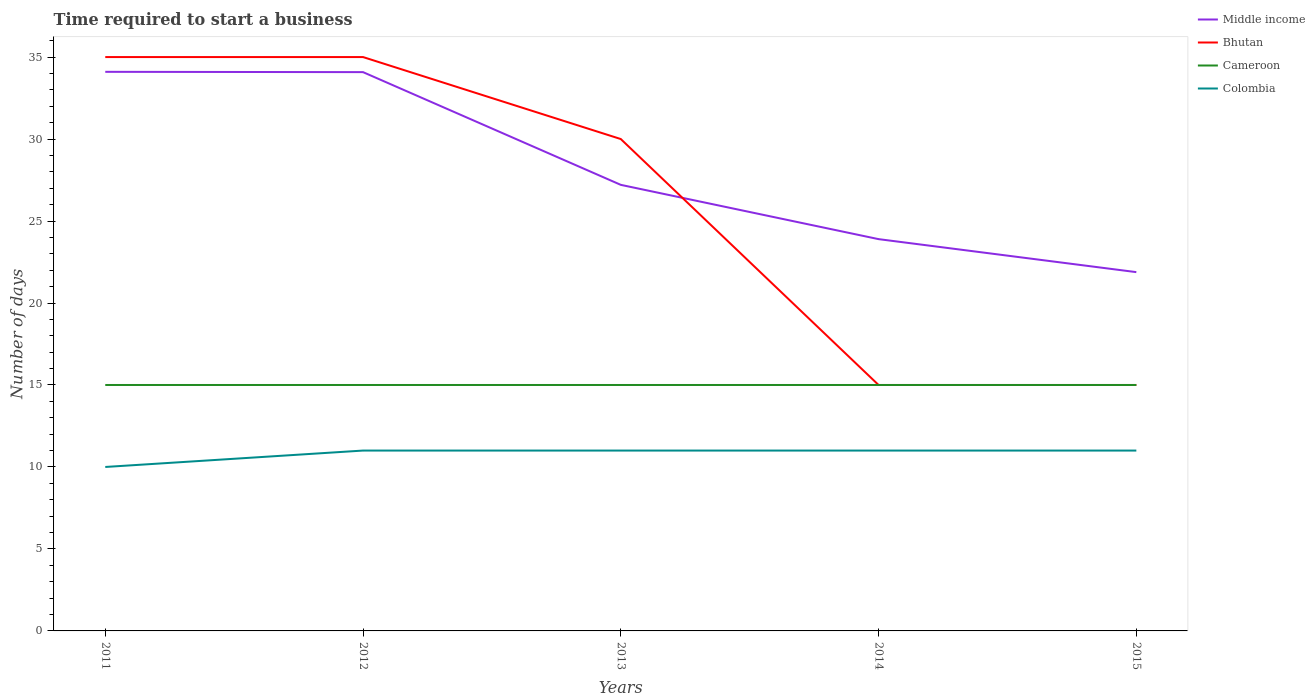How many different coloured lines are there?
Your response must be concise. 4. Is the number of lines equal to the number of legend labels?
Offer a very short reply. Yes. Across all years, what is the maximum number of days required to start a business in Bhutan?
Keep it short and to the point. 15. In which year was the number of days required to start a business in Middle income maximum?
Your answer should be compact. 2015. What is the difference between the highest and the second highest number of days required to start a business in Middle income?
Provide a succinct answer. 12.22. What is the difference between the highest and the lowest number of days required to start a business in Bhutan?
Ensure brevity in your answer.  3. Is the number of days required to start a business in Bhutan strictly greater than the number of days required to start a business in Cameroon over the years?
Offer a very short reply. No. How many lines are there?
Your response must be concise. 4. Are the values on the major ticks of Y-axis written in scientific E-notation?
Your answer should be very brief. No. Where does the legend appear in the graph?
Your answer should be very brief. Top right. How are the legend labels stacked?
Make the answer very short. Vertical. What is the title of the graph?
Ensure brevity in your answer.  Time required to start a business. Does "Greenland" appear as one of the legend labels in the graph?
Give a very brief answer. No. What is the label or title of the X-axis?
Your answer should be compact. Years. What is the label or title of the Y-axis?
Your answer should be compact. Number of days. What is the Number of days in Middle income in 2011?
Provide a succinct answer. 34.1. What is the Number of days in Cameroon in 2011?
Keep it short and to the point. 15. What is the Number of days in Colombia in 2011?
Offer a terse response. 10. What is the Number of days in Middle income in 2012?
Keep it short and to the point. 34.08. What is the Number of days in Bhutan in 2012?
Your response must be concise. 35. What is the Number of days of Cameroon in 2012?
Your response must be concise. 15. What is the Number of days in Colombia in 2012?
Give a very brief answer. 11. What is the Number of days in Middle income in 2013?
Provide a succinct answer. 27.21. What is the Number of days of Bhutan in 2013?
Your answer should be very brief. 30. What is the Number of days in Cameroon in 2013?
Offer a very short reply. 15. What is the Number of days of Colombia in 2013?
Make the answer very short. 11. What is the Number of days in Middle income in 2014?
Ensure brevity in your answer.  23.9. What is the Number of days in Bhutan in 2014?
Your response must be concise. 15. What is the Number of days of Cameroon in 2014?
Offer a terse response. 15. What is the Number of days of Middle income in 2015?
Your answer should be compact. 21.88. What is the Number of days of Bhutan in 2015?
Your answer should be compact. 15. What is the Number of days of Cameroon in 2015?
Provide a succinct answer. 15. Across all years, what is the maximum Number of days in Middle income?
Ensure brevity in your answer.  34.1. Across all years, what is the maximum Number of days of Colombia?
Make the answer very short. 11. Across all years, what is the minimum Number of days in Middle income?
Ensure brevity in your answer.  21.88. Across all years, what is the minimum Number of days of Colombia?
Your answer should be very brief. 10. What is the total Number of days in Middle income in the graph?
Make the answer very short. 141.17. What is the total Number of days in Bhutan in the graph?
Provide a short and direct response. 130. What is the difference between the Number of days in Middle income in 2011 and that in 2012?
Provide a succinct answer. 0.02. What is the difference between the Number of days of Middle income in 2011 and that in 2013?
Your answer should be very brief. 6.89. What is the difference between the Number of days in Bhutan in 2011 and that in 2013?
Offer a terse response. 5. What is the difference between the Number of days of Cameroon in 2011 and that in 2013?
Provide a succinct answer. 0. What is the difference between the Number of days in Middle income in 2011 and that in 2014?
Provide a succinct answer. 10.2. What is the difference between the Number of days in Bhutan in 2011 and that in 2014?
Offer a terse response. 20. What is the difference between the Number of days in Cameroon in 2011 and that in 2014?
Make the answer very short. 0. What is the difference between the Number of days of Colombia in 2011 and that in 2014?
Provide a short and direct response. -1. What is the difference between the Number of days of Middle income in 2011 and that in 2015?
Your answer should be compact. 12.22. What is the difference between the Number of days of Cameroon in 2011 and that in 2015?
Offer a very short reply. 0. What is the difference between the Number of days in Middle income in 2012 and that in 2013?
Provide a short and direct response. 6.88. What is the difference between the Number of days of Bhutan in 2012 and that in 2013?
Your answer should be compact. 5. What is the difference between the Number of days in Colombia in 2012 and that in 2013?
Your response must be concise. 0. What is the difference between the Number of days of Middle income in 2012 and that in 2014?
Offer a very short reply. 10.19. What is the difference between the Number of days of Bhutan in 2012 and that in 2014?
Your answer should be compact. 20. What is the difference between the Number of days of Colombia in 2012 and that in 2014?
Ensure brevity in your answer.  0. What is the difference between the Number of days of Middle income in 2012 and that in 2015?
Your answer should be compact. 12.2. What is the difference between the Number of days in Cameroon in 2012 and that in 2015?
Your response must be concise. 0. What is the difference between the Number of days of Colombia in 2012 and that in 2015?
Give a very brief answer. 0. What is the difference between the Number of days of Middle income in 2013 and that in 2014?
Your answer should be compact. 3.31. What is the difference between the Number of days of Cameroon in 2013 and that in 2014?
Ensure brevity in your answer.  0. What is the difference between the Number of days in Colombia in 2013 and that in 2014?
Ensure brevity in your answer.  0. What is the difference between the Number of days in Middle income in 2013 and that in 2015?
Provide a succinct answer. 5.32. What is the difference between the Number of days in Bhutan in 2013 and that in 2015?
Make the answer very short. 15. What is the difference between the Number of days in Middle income in 2014 and that in 2015?
Provide a succinct answer. 2.01. What is the difference between the Number of days of Bhutan in 2014 and that in 2015?
Ensure brevity in your answer.  0. What is the difference between the Number of days of Cameroon in 2014 and that in 2015?
Your response must be concise. 0. What is the difference between the Number of days of Colombia in 2014 and that in 2015?
Your answer should be very brief. 0. What is the difference between the Number of days of Middle income in 2011 and the Number of days of Bhutan in 2012?
Make the answer very short. -0.9. What is the difference between the Number of days in Middle income in 2011 and the Number of days in Cameroon in 2012?
Offer a terse response. 19.1. What is the difference between the Number of days in Middle income in 2011 and the Number of days in Colombia in 2012?
Offer a very short reply. 23.1. What is the difference between the Number of days of Bhutan in 2011 and the Number of days of Cameroon in 2012?
Offer a very short reply. 20. What is the difference between the Number of days of Bhutan in 2011 and the Number of days of Colombia in 2012?
Your response must be concise. 24. What is the difference between the Number of days of Middle income in 2011 and the Number of days of Bhutan in 2013?
Your response must be concise. 4.1. What is the difference between the Number of days in Middle income in 2011 and the Number of days in Colombia in 2013?
Give a very brief answer. 23.1. What is the difference between the Number of days in Cameroon in 2011 and the Number of days in Colombia in 2013?
Your answer should be compact. 4. What is the difference between the Number of days in Middle income in 2011 and the Number of days in Cameroon in 2014?
Ensure brevity in your answer.  19.1. What is the difference between the Number of days in Middle income in 2011 and the Number of days in Colombia in 2014?
Your answer should be very brief. 23.1. What is the difference between the Number of days of Bhutan in 2011 and the Number of days of Cameroon in 2014?
Your response must be concise. 20. What is the difference between the Number of days in Bhutan in 2011 and the Number of days in Colombia in 2014?
Ensure brevity in your answer.  24. What is the difference between the Number of days in Middle income in 2011 and the Number of days in Bhutan in 2015?
Provide a succinct answer. 19.1. What is the difference between the Number of days in Middle income in 2011 and the Number of days in Cameroon in 2015?
Your answer should be very brief. 19.1. What is the difference between the Number of days of Middle income in 2011 and the Number of days of Colombia in 2015?
Offer a very short reply. 23.1. What is the difference between the Number of days of Bhutan in 2011 and the Number of days of Cameroon in 2015?
Give a very brief answer. 20. What is the difference between the Number of days in Bhutan in 2011 and the Number of days in Colombia in 2015?
Your response must be concise. 24. What is the difference between the Number of days in Cameroon in 2011 and the Number of days in Colombia in 2015?
Your answer should be very brief. 4. What is the difference between the Number of days of Middle income in 2012 and the Number of days of Bhutan in 2013?
Make the answer very short. 4.08. What is the difference between the Number of days of Middle income in 2012 and the Number of days of Cameroon in 2013?
Make the answer very short. 19.08. What is the difference between the Number of days of Middle income in 2012 and the Number of days of Colombia in 2013?
Your answer should be very brief. 23.08. What is the difference between the Number of days in Bhutan in 2012 and the Number of days in Cameroon in 2013?
Give a very brief answer. 20. What is the difference between the Number of days in Cameroon in 2012 and the Number of days in Colombia in 2013?
Your answer should be very brief. 4. What is the difference between the Number of days in Middle income in 2012 and the Number of days in Bhutan in 2014?
Provide a short and direct response. 19.08. What is the difference between the Number of days of Middle income in 2012 and the Number of days of Cameroon in 2014?
Make the answer very short. 19.08. What is the difference between the Number of days of Middle income in 2012 and the Number of days of Colombia in 2014?
Offer a very short reply. 23.08. What is the difference between the Number of days in Bhutan in 2012 and the Number of days in Cameroon in 2014?
Give a very brief answer. 20. What is the difference between the Number of days in Middle income in 2012 and the Number of days in Bhutan in 2015?
Provide a succinct answer. 19.08. What is the difference between the Number of days of Middle income in 2012 and the Number of days of Cameroon in 2015?
Give a very brief answer. 19.08. What is the difference between the Number of days of Middle income in 2012 and the Number of days of Colombia in 2015?
Your answer should be compact. 23.08. What is the difference between the Number of days of Bhutan in 2012 and the Number of days of Cameroon in 2015?
Your answer should be very brief. 20. What is the difference between the Number of days of Bhutan in 2012 and the Number of days of Colombia in 2015?
Provide a short and direct response. 24. What is the difference between the Number of days in Middle income in 2013 and the Number of days in Bhutan in 2014?
Provide a short and direct response. 12.21. What is the difference between the Number of days in Middle income in 2013 and the Number of days in Cameroon in 2014?
Offer a terse response. 12.21. What is the difference between the Number of days of Middle income in 2013 and the Number of days of Colombia in 2014?
Offer a very short reply. 16.21. What is the difference between the Number of days of Bhutan in 2013 and the Number of days of Cameroon in 2014?
Provide a succinct answer. 15. What is the difference between the Number of days in Bhutan in 2013 and the Number of days in Colombia in 2014?
Your response must be concise. 19. What is the difference between the Number of days in Middle income in 2013 and the Number of days in Bhutan in 2015?
Your answer should be compact. 12.21. What is the difference between the Number of days in Middle income in 2013 and the Number of days in Cameroon in 2015?
Your response must be concise. 12.21. What is the difference between the Number of days in Middle income in 2013 and the Number of days in Colombia in 2015?
Give a very brief answer. 16.21. What is the difference between the Number of days of Middle income in 2014 and the Number of days of Bhutan in 2015?
Make the answer very short. 8.9. What is the difference between the Number of days in Middle income in 2014 and the Number of days in Cameroon in 2015?
Your response must be concise. 8.9. What is the difference between the Number of days of Middle income in 2014 and the Number of days of Colombia in 2015?
Your response must be concise. 12.9. What is the difference between the Number of days of Bhutan in 2014 and the Number of days of Cameroon in 2015?
Make the answer very short. 0. What is the average Number of days of Middle income per year?
Your answer should be very brief. 28.23. What is the average Number of days of Bhutan per year?
Your answer should be very brief. 26. What is the average Number of days of Colombia per year?
Your answer should be compact. 10.8. In the year 2011, what is the difference between the Number of days in Middle income and Number of days in Cameroon?
Offer a terse response. 19.1. In the year 2011, what is the difference between the Number of days of Middle income and Number of days of Colombia?
Provide a succinct answer. 24.1. In the year 2011, what is the difference between the Number of days in Bhutan and Number of days in Cameroon?
Offer a very short reply. 20. In the year 2011, what is the difference between the Number of days of Cameroon and Number of days of Colombia?
Keep it short and to the point. 5. In the year 2012, what is the difference between the Number of days of Middle income and Number of days of Bhutan?
Offer a very short reply. -0.92. In the year 2012, what is the difference between the Number of days of Middle income and Number of days of Cameroon?
Make the answer very short. 19.08. In the year 2012, what is the difference between the Number of days in Middle income and Number of days in Colombia?
Your answer should be very brief. 23.08. In the year 2012, what is the difference between the Number of days in Bhutan and Number of days in Cameroon?
Offer a terse response. 20. In the year 2012, what is the difference between the Number of days of Cameroon and Number of days of Colombia?
Your response must be concise. 4. In the year 2013, what is the difference between the Number of days in Middle income and Number of days in Bhutan?
Keep it short and to the point. -2.79. In the year 2013, what is the difference between the Number of days in Middle income and Number of days in Cameroon?
Provide a short and direct response. 12.21. In the year 2013, what is the difference between the Number of days of Middle income and Number of days of Colombia?
Make the answer very short. 16.21. In the year 2013, what is the difference between the Number of days of Bhutan and Number of days of Cameroon?
Ensure brevity in your answer.  15. In the year 2013, what is the difference between the Number of days in Bhutan and Number of days in Colombia?
Your response must be concise. 19. In the year 2014, what is the difference between the Number of days of Middle income and Number of days of Bhutan?
Give a very brief answer. 8.9. In the year 2014, what is the difference between the Number of days in Middle income and Number of days in Cameroon?
Keep it short and to the point. 8.9. In the year 2014, what is the difference between the Number of days of Middle income and Number of days of Colombia?
Provide a succinct answer. 12.9. In the year 2014, what is the difference between the Number of days of Bhutan and Number of days of Cameroon?
Keep it short and to the point. 0. In the year 2015, what is the difference between the Number of days of Middle income and Number of days of Bhutan?
Provide a succinct answer. 6.88. In the year 2015, what is the difference between the Number of days in Middle income and Number of days in Cameroon?
Ensure brevity in your answer.  6.88. In the year 2015, what is the difference between the Number of days of Middle income and Number of days of Colombia?
Offer a terse response. 10.88. In the year 2015, what is the difference between the Number of days in Bhutan and Number of days in Cameroon?
Ensure brevity in your answer.  0. What is the ratio of the Number of days of Cameroon in 2011 to that in 2012?
Your answer should be compact. 1. What is the ratio of the Number of days in Colombia in 2011 to that in 2012?
Your response must be concise. 0.91. What is the ratio of the Number of days of Middle income in 2011 to that in 2013?
Provide a succinct answer. 1.25. What is the ratio of the Number of days of Bhutan in 2011 to that in 2013?
Your answer should be compact. 1.17. What is the ratio of the Number of days of Cameroon in 2011 to that in 2013?
Offer a terse response. 1. What is the ratio of the Number of days in Colombia in 2011 to that in 2013?
Your response must be concise. 0.91. What is the ratio of the Number of days of Middle income in 2011 to that in 2014?
Your answer should be compact. 1.43. What is the ratio of the Number of days in Bhutan in 2011 to that in 2014?
Your answer should be compact. 2.33. What is the ratio of the Number of days of Cameroon in 2011 to that in 2014?
Your answer should be compact. 1. What is the ratio of the Number of days of Colombia in 2011 to that in 2014?
Give a very brief answer. 0.91. What is the ratio of the Number of days in Middle income in 2011 to that in 2015?
Your response must be concise. 1.56. What is the ratio of the Number of days in Bhutan in 2011 to that in 2015?
Provide a short and direct response. 2.33. What is the ratio of the Number of days in Cameroon in 2011 to that in 2015?
Your answer should be very brief. 1. What is the ratio of the Number of days of Colombia in 2011 to that in 2015?
Offer a very short reply. 0.91. What is the ratio of the Number of days of Middle income in 2012 to that in 2013?
Provide a succinct answer. 1.25. What is the ratio of the Number of days of Bhutan in 2012 to that in 2013?
Your answer should be compact. 1.17. What is the ratio of the Number of days in Cameroon in 2012 to that in 2013?
Offer a very short reply. 1. What is the ratio of the Number of days of Middle income in 2012 to that in 2014?
Provide a succinct answer. 1.43. What is the ratio of the Number of days in Bhutan in 2012 to that in 2014?
Provide a succinct answer. 2.33. What is the ratio of the Number of days of Middle income in 2012 to that in 2015?
Your answer should be compact. 1.56. What is the ratio of the Number of days of Bhutan in 2012 to that in 2015?
Provide a short and direct response. 2.33. What is the ratio of the Number of days of Middle income in 2013 to that in 2014?
Provide a succinct answer. 1.14. What is the ratio of the Number of days of Bhutan in 2013 to that in 2014?
Offer a terse response. 2. What is the ratio of the Number of days in Cameroon in 2013 to that in 2014?
Offer a very short reply. 1. What is the ratio of the Number of days of Colombia in 2013 to that in 2014?
Give a very brief answer. 1. What is the ratio of the Number of days of Middle income in 2013 to that in 2015?
Offer a terse response. 1.24. What is the ratio of the Number of days of Middle income in 2014 to that in 2015?
Make the answer very short. 1.09. What is the ratio of the Number of days of Cameroon in 2014 to that in 2015?
Keep it short and to the point. 1. What is the ratio of the Number of days in Colombia in 2014 to that in 2015?
Your response must be concise. 1. What is the difference between the highest and the second highest Number of days in Middle income?
Your answer should be very brief. 0.02. What is the difference between the highest and the second highest Number of days of Bhutan?
Offer a terse response. 0. What is the difference between the highest and the second highest Number of days of Cameroon?
Your answer should be very brief. 0. What is the difference between the highest and the second highest Number of days in Colombia?
Your answer should be compact. 0. What is the difference between the highest and the lowest Number of days in Middle income?
Your response must be concise. 12.22. What is the difference between the highest and the lowest Number of days in Cameroon?
Give a very brief answer. 0. 